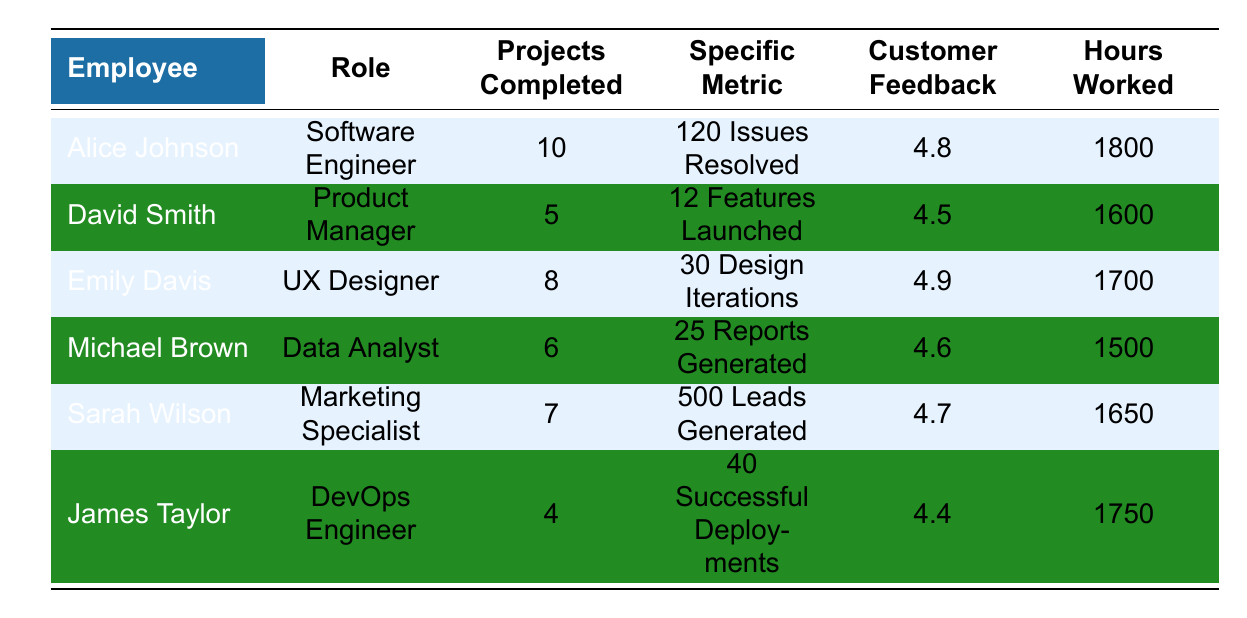What is the highest customer feedback score among the employees? The highest customer feedback score in the table is found in the row for Emily Davis, who has a score of 4.9.
Answer: 4.9 Which employee worked the most hours? By comparing the "Hours Worked" column, Alice Johnson has the most hours at 1800.
Answer: Alice Johnson How many projects did Sarah Wilson complete? The table shows that Sarah Wilson completed 7 projects.
Answer: 7 What is the average number of projects completed by all employees? To find the average, sum the projects completed (10 + 5 + 8 + 6 + 7 + 4 = 40) and divide by the number of employees (6): 40/6 = 6.67.
Answer: 6.67 Did Michael Brown generate more reports than issues resolved by Alice Johnson? Alice Johnson resolved 120 issues, while Michael Brown generated 25 reports; thus, Michael did not generate more reports.
Answer: No Which role has the least customer feedback score? Looking at the customer feedback scores, James Taylor (DevOps Engineer) with a score of 4.4 has the lowest score.
Answer: James Taylor How many total leads did Sarah Wilson generate compared to the total hours worked by all employees? Sarah Wilson generated 500 leads. The total hours worked by all employees is 1800 + 1600 + 1700 + 1500 + 1650 + 1750 = 11500 hours. The question asks for both values, so we can state that 500 leads were generated with a total of 11500 hours worked.
Answer: 500 leads, 11500 hours Which employee completed the fewest projects, and how many? James Taylor completed only 4 projects, which is the least among all employees listed in the table.
Answer: James Taylor; 4 projects What is the difference in hours worked between Alice Johnson and David Smith? Alice Johnson worked 1800 hours and David Smith worked 1600 hours. The difference is 1800 - 1600 = 200 hours.
Answer: 200 hours How many issues did Emily Davis resolve compared to features launched by David Smith? Emily Davis's data does not include issues resolved but includes design iterations (30), while David Smith launched 12 features. Thus, the comparison is not directly between issues and features. However, in the table, we cannot derive Emily's issues from the data, only that David launched 12 features.
Answer: Not directly comparable; Emily's issues resolved not provided 